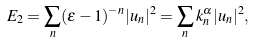Convert formula to latex. <formula><loc_0><loc_0><loc_500><loc_500>E _ { 2 } = \sum _ { n } ( \epsilon - 1 ) ^ { - n } | u _ { n } | ^ { 2 } = \sum _ { n } k _ { n } ^ { \alpha } | u _ { n } | ^ { 2 } ,</formula> 